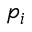Convert formula to latex. <formula><loc_0><loc_0><loc_500><loc_500>p _ { i }</formula> 